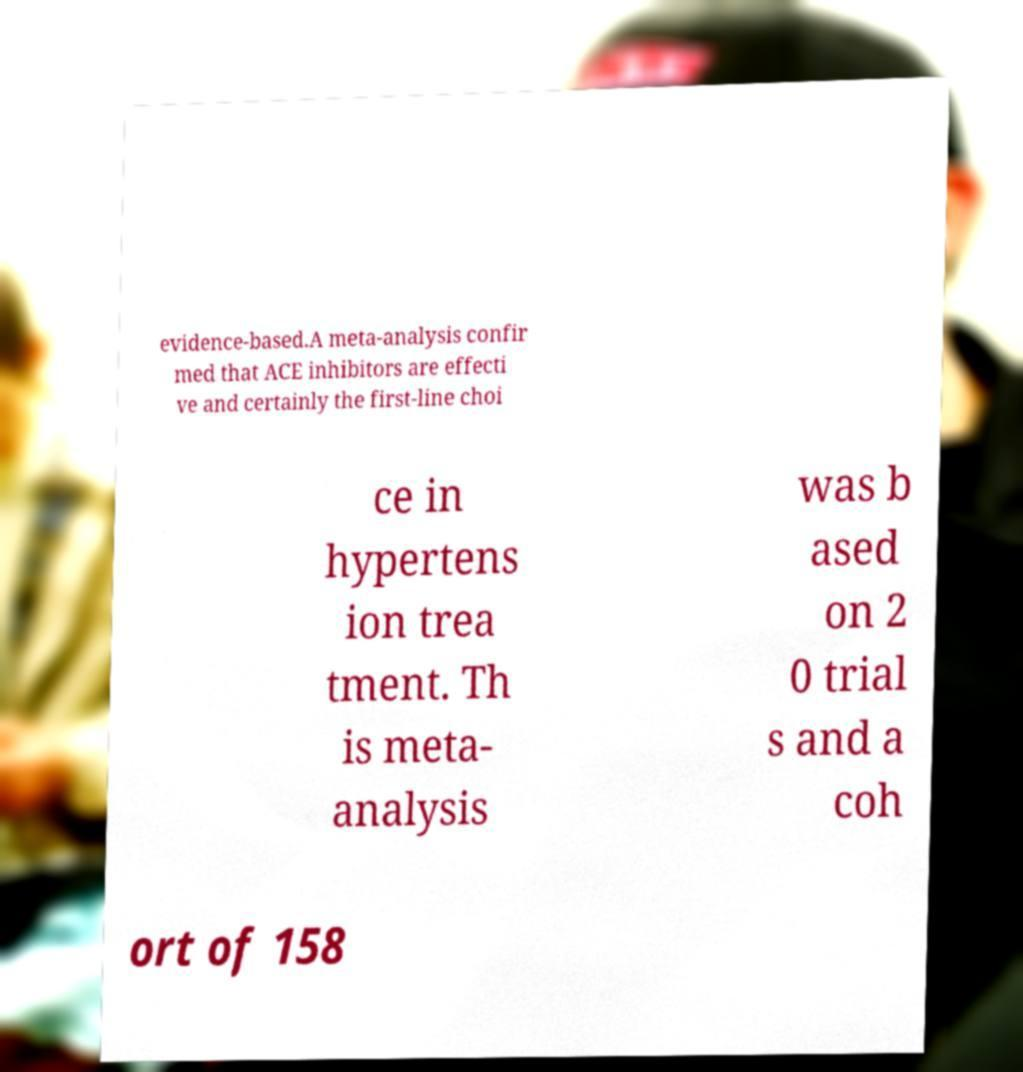Can you accurately transcribe the text from the provided image for me? evidence-based.A meta-analysis confir med that ACE inhibitors are effecti ve and certainly the first-line choi ce in hypertens ion trea tment. Th is meta- analysis was b ased on 2 0 trial s and a coh ort of 158 